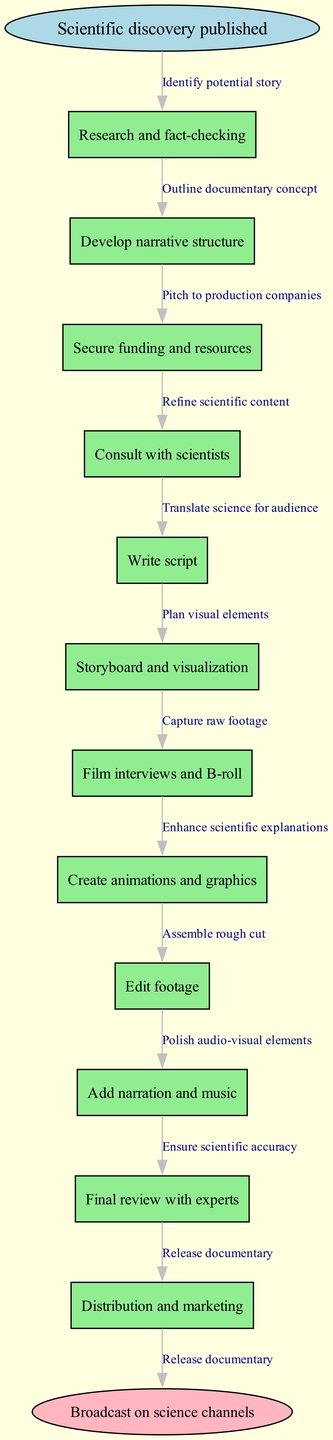What is the starting point of the process? The starting point is explicitly labeled in the diagram as "Scientific discovery published."
Answer: Scientific discovery published How many nodes are in the diagram? By counting the nodes listed, there are 12 total nodes including the starting and ending nodes.
Answer: 12 What is the final step of the process? The final step is designated in the diagram as "Broadcast on science channels."
Answer: Broadcast on science channels What is the relationship between "Research and fact-checking" and "Develop narrative structure"? The edge connecting these two nodes, labeled "Identify potential story," shows that developing the narrative structure follows the research and fact-checking.
Answer: Identify potential story Which node directly follows "Write script"? Following "Write script" is the node "Storyboard and visualization," indicating the sequence of steps in the process.
Answer: Storyboard and visualization What is the primary action taken after securing funding and resources? The primary action immediately following securing funding is "Consult with scientists," establishing a clear flow in the process.
Answer: Consult with scientists What step comes after "Edit footage"? The step that directly follows "Edit footage" is "Add narration and music," indicating the next phase of production.
Answer: Add narration and music Which step involves working with experts? The process involves experts during the "Final review with experts," indicating the importance of accuracy.
Answer: Final review with experts How many edges connect the nodes in the diagram? The edges represent the relationships between the nodes; there are a total of 11 edges connecting the 12 nodes.
Answer: 11 